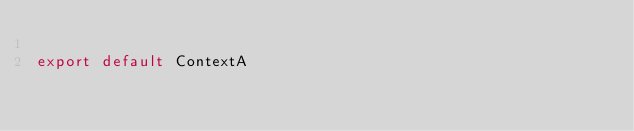Convert code to text. <code><loc_0><loc_0><loc_500><loc_500><_TypeScript_>
export default ContextA</code> 